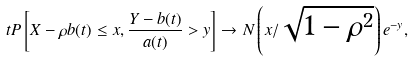Convert formula to latex. <formula><loc_0><loc_0><loc_500><loc_500>t P \left [ X - \rho b ( t ) \leq x , \frac { Y - b ( t ) } { a ( t ) } > y \right ] \to N \left ( x / \sqrt { 1 - \rho ^ { 2 } } \right ) e ^ { - y } ,</formula> 